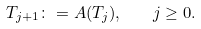<formula> <loc_0><loc_0><loc_500><loc_500>T _ { j + 1 } \colon = A ( T _ { j } ) , \quad j \geq 0 .</formula> 